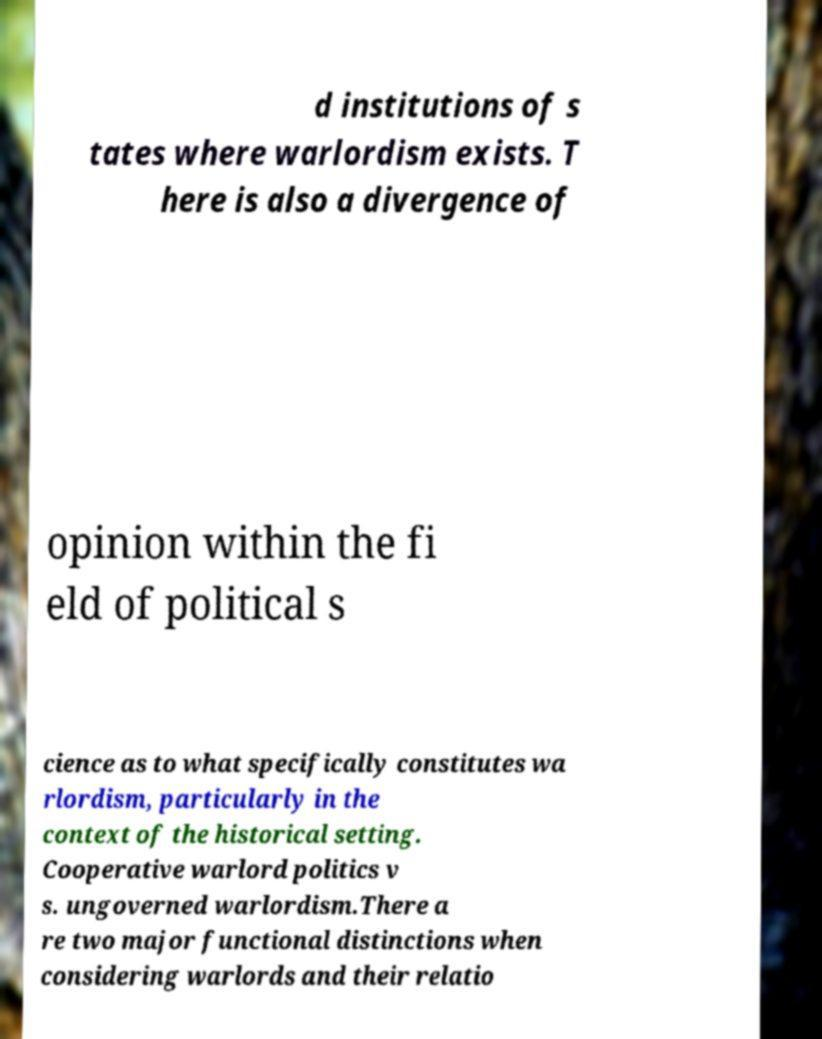I need the written content from this picture converted into text. Can you do that? d institutions of s tates where warlordism exists. T here is also a divergence of opinion within the fi eld of political s cience as to what specifically constitutes wa rlordism, particularly in the context of the historical setting. Cooperative warlord politics v s. ungoverned warlordism.There a re two major functional distinctions when considering warlords and their relatio 